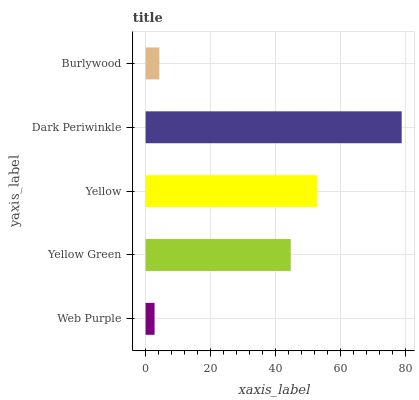Is Web Purple the minimum?
Answer yes or no. Yes. Is Dark Periwinkle the maximum?
Answer yes or no. Yes. Is Yellow Green the minimum?
Answer yes or no. No. Is Yellow Green the maximum?
Answer yes or no. No. Is Yellow Green greater than Web Purple?
Answer yes or no. Yes. Is Web Purple less than Yellow Green?
Answer yes or no. Yes. Is Web Purple greater than Yellow Green?
Answer yes or no. No. Is Yellow Green less than Web Purple?
Answer yes or no. No. Is Yellow Green the high median?
Answer yes or no. Yes. Is Yellow Green the low median?
Answer yes or no. Yes. Is Yellow the high median?
Answer yes or no. No. Is Dark Periwinkle the low median?
Answer yes or no. No. 